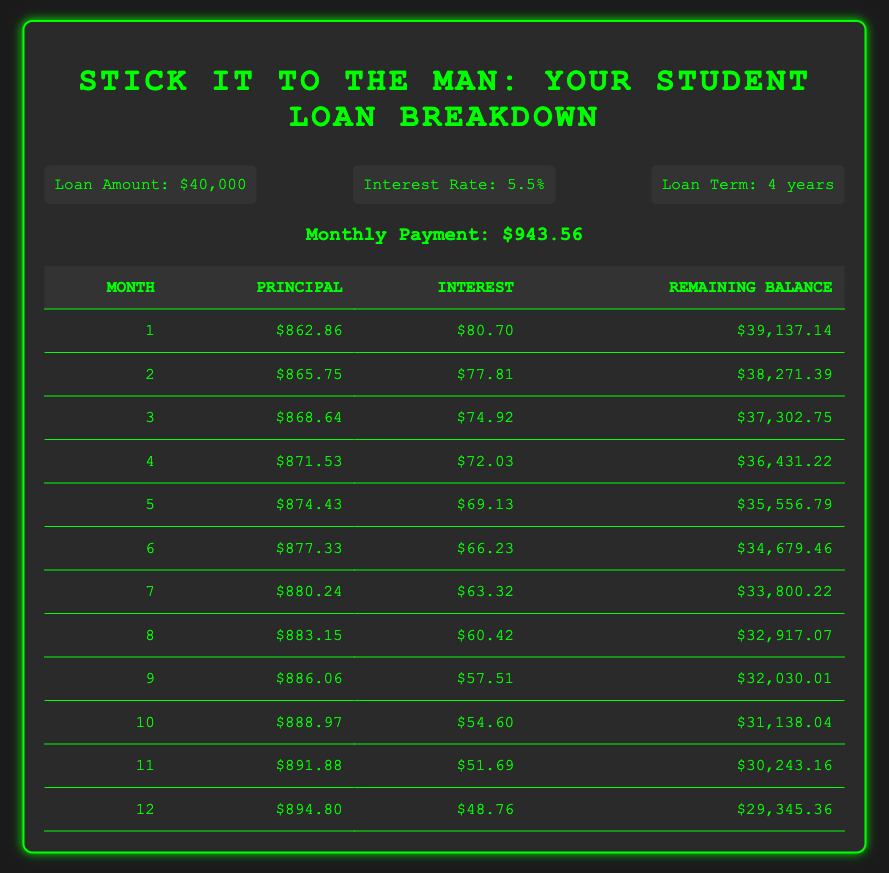What's the principal payment for the 3rd month? The table lists the principal payment for the 3rd month as $868.64. This value can be found by looking at the row for month 3 in the amortization schedule.
Answer: 868.64 What is the total interest paid in the first year? The total interest for the first year can be calculated by summing the interest payments for each month from 1 to 12. The monthly interest payments for months 1 to 12 are $80.70, $77.81, $74.92, $72.03, $69.13, $66.23, $63.32, $60.42, $57.51, $54.60, $51.69, and $48.76. Adding these values gives a total of $819.68.
Answer: 819.68 Is the interest payment for the 6th month lower than $70? The interest payment for the 6th month is $66.23, which is indeed lower than $70. This value is directly taken from the row for month 6 in the table.
Answer: Yes What is the remaining balance after the 7th month? The remaining balance after the 7th month is shown as $33,800.22 in the table, directly corresponding to the row for month 7.
Answer: 33,800.22 What is the difference between the principal payment of the 5th and 2nd months? The principal payment for the 5th month is $874.43, and for the 2nd month, it is $865.75. To find the difference, we subtract the 2nd month value from the 5th month value: $874.43 - $865.75 = $8.68.
Answer: 8.68 How much total will be paid in principal over the first 12 months? To find the total principal paid over the first 12 months, we sum the principal payments for each month from 1 to 12. Those amounts are $862.86, $865.75, $868.64, $871.53, $874.43, $877.33, $880.24, $883.15, $886.06, $888.97, $891.88, and $894.80, which totals $10,619.17. This can be found by direct addition of all these values.
Answer: 10,619.17 Is the average interest payment in the first year greater than $60? The average interest payment can be calculated by summing the interest payments for the first 12 months and then dividing by 12. The sum of the interest payments is $819.68, and dividing by 12 gives an average interest payment of approximately $68.31, which is greater than $60.
Answer: Yes What is the principal payment for the last month of the first year? The principal payment for the last month of the first year, which is the 12th month, is $894.80 according to the table. This value is taken from the row for month 12.
Answer: 894.80 